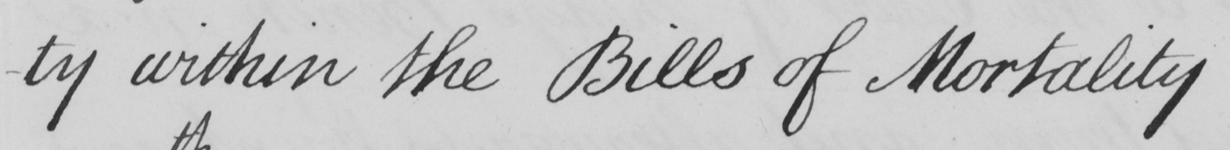Please transcribe the handwritten text in this image. -ty within the Bills of Mortality 